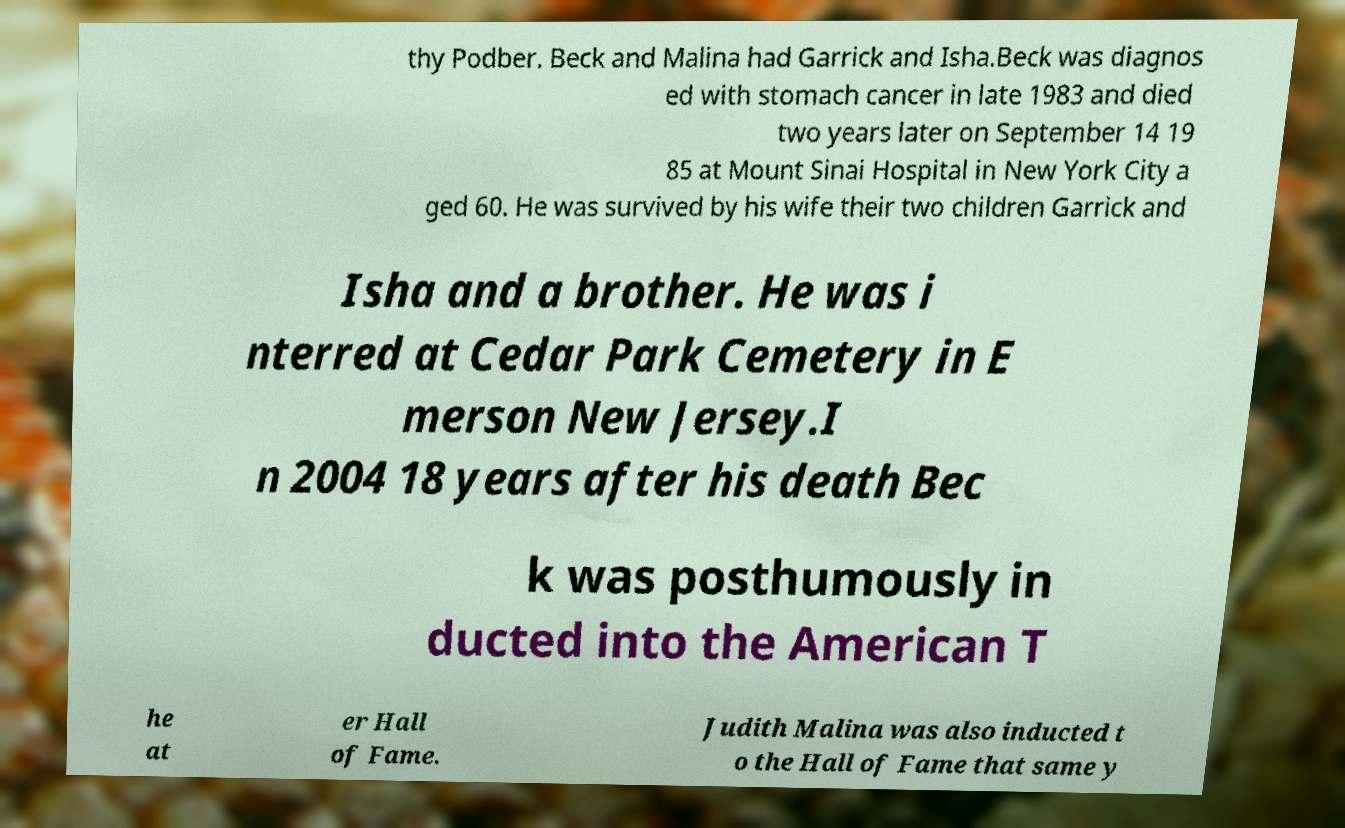What was the significance of Beck's induction into the American Theater Hall of Fame? Beck's induction into the American Theater Hall of Fame 18 years after his death recognizes his lasting impact on theatrical arts. His innovative approaches to theater production, direction, and his commitment to recounting social issues through drama significantly shaped modern theater. This induction serves as an acknowledgment of his contributions to enriching and transforming American theater. 